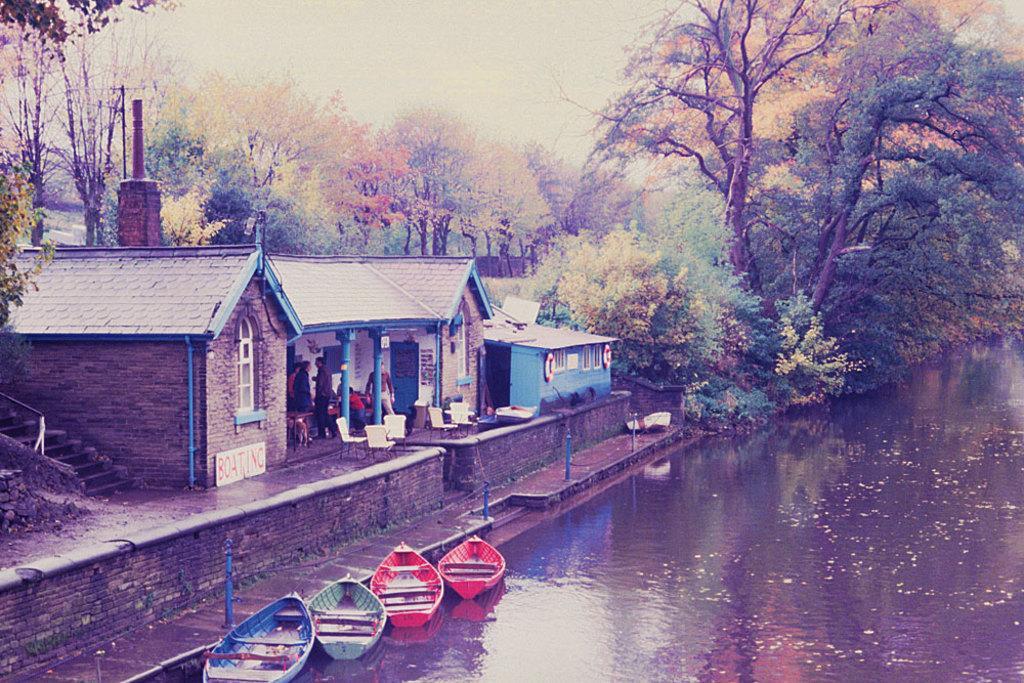In one or two sentences, can you explain what this image depicts? At the bottom of the image there is a lake and we can see boats in the lake. On the left there are sheds and we can see people standing in the sheds. In the background there are trees and sky. 